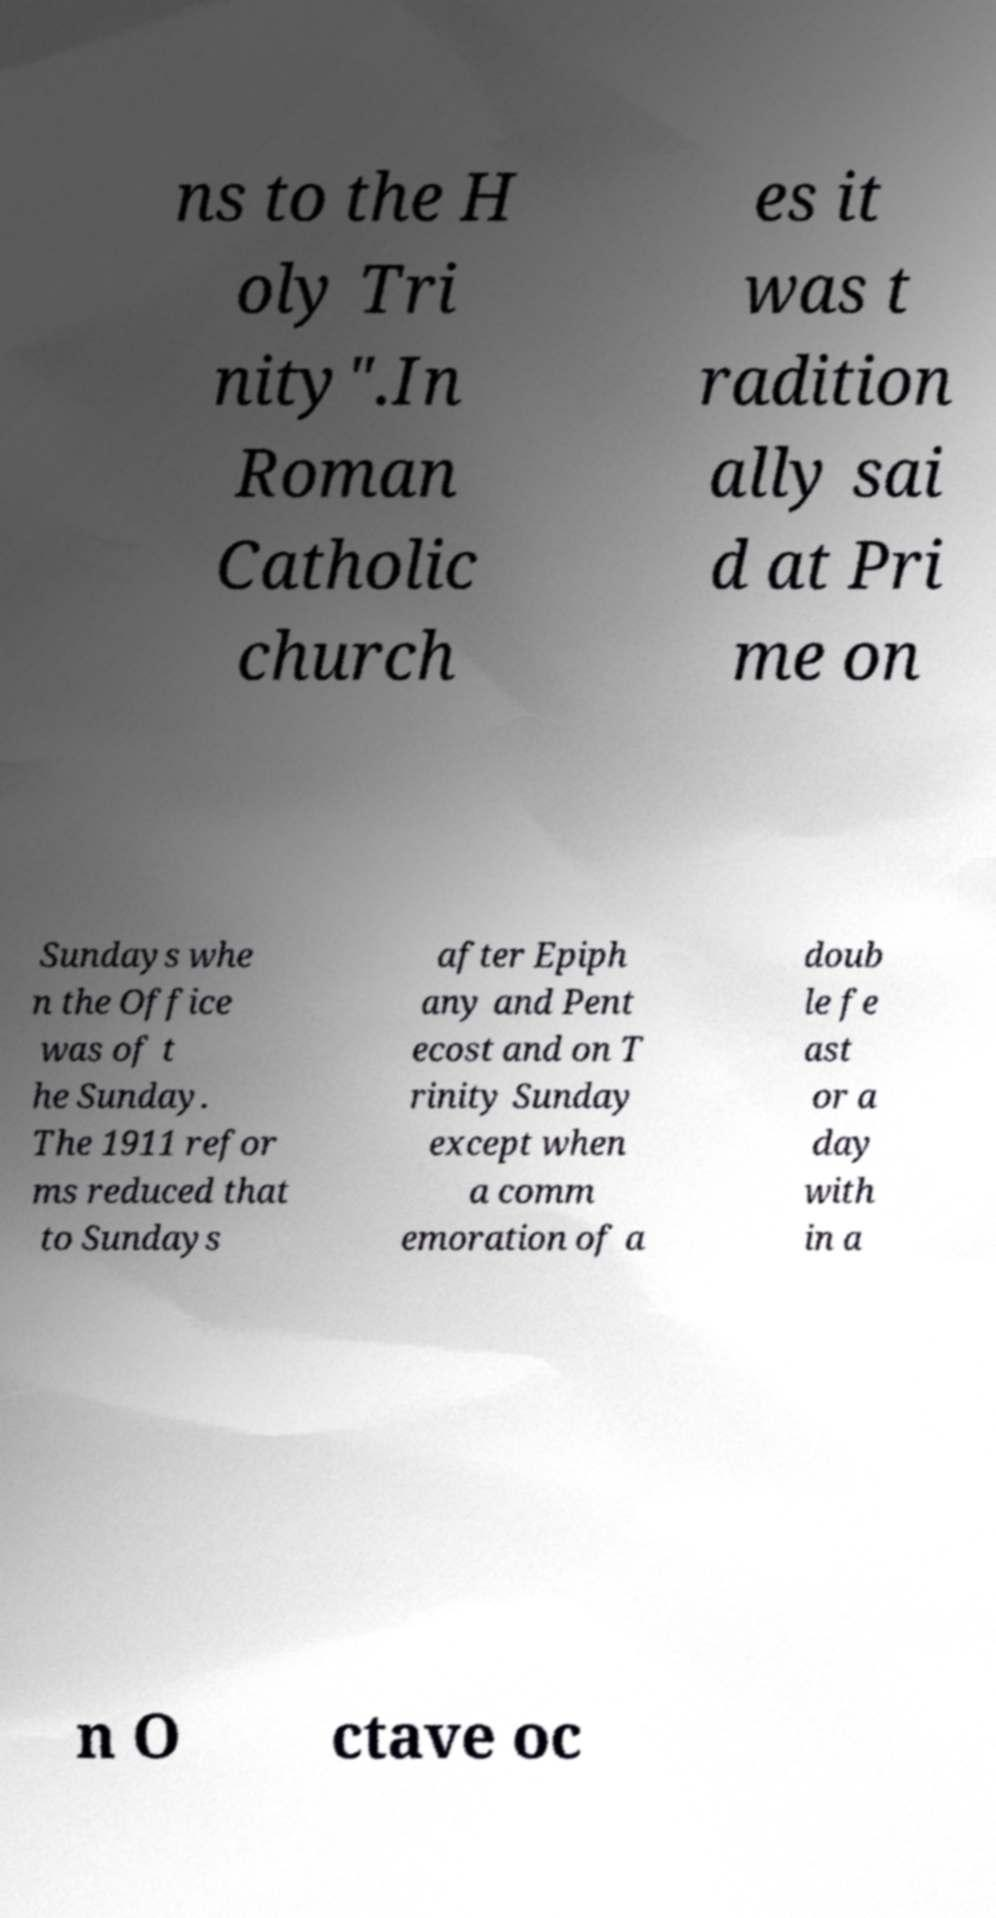Please read and relay the text visible in this image. What does it say? ns to the H oly Tri nity".In Roman Catholic church es it was t radition ally sai d at Pri me on Sundays whe n the Office was of t he Sunday. The 1911 refor ms reduced that to Sundays after Epiph any and Pent ecost and on T rinity Sunday except when a comm emoration of a doub le fe ast or a day with in a n O ctave oc 